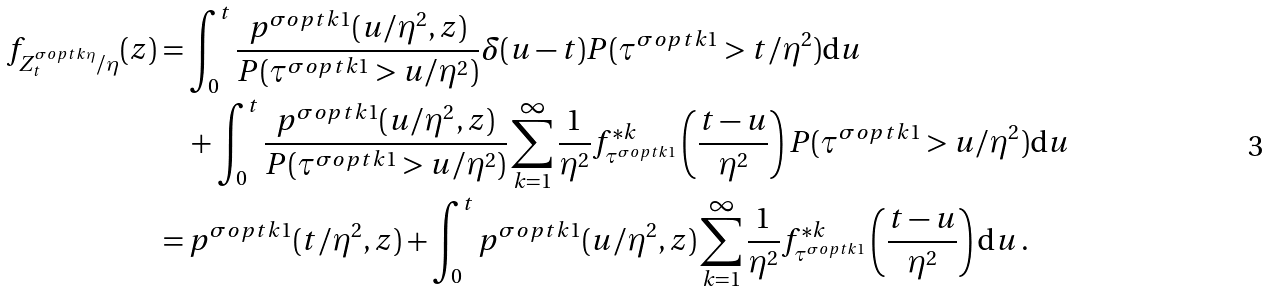<formula> <loc_0><loc_0><loc_500><loc_500>f _ { Z ^ { \sigma o p t k \eta } _ { t } / \eta } ( z ) & = \int _ { 0 } ^ { t } \frac { p ^ { \sigma o p t k 1 } ( u / \eta ^ { 2 } , z ) } { P ( \tau ^ { \sigma o p t k 1 } > u / \eta ^ { 2 } ) } \delta ( u - t ) P ( \tau ^ { \sigma o p t k 1 } > t / \eta ^ { 2 } ) \text {d} u \\ & \quad + \int _ { 0 } ^ { t } \frac { p ^ { \sigma o p t k 1 } ( u / \eta ^ { 2 } , z ) } { P ( \tau ^ { \sigma o p t k 1 } > u / \eta ^ { 2 } ) } \sum _ { k = 1 } ^ { \infty } \frac { 1 } { \eta ^ { 2 } } f _ { \tau ^ { \sigma o p t k 1 } } ^ { * k } \left ( \frac { t - u } { \eta ^ { 2 } } \right ) P ( \tau ^ { \sigma o p t k 1 } > u / \eta ^ { 2 } ) \text {d} u \\ & = p ^ { \sigma o p t k 1 } ( t / \eta ^ { 2 } , z ) + \int _ { 0 } ^ { t } p ^ { \sigma o p t k 1 } ( u / \eta ^ { 2 } , z ) \sum _ { k = 1 } ^ { \infty } \frac { 1 } { \eta ^ { 2 } } f _ { \tau ^ { \sigma o p t k 1 } } ^ { * k } \left ( \frac { t - u } { \eta ^ { 2 } } \right ) \text {d} u \, .</formula> 